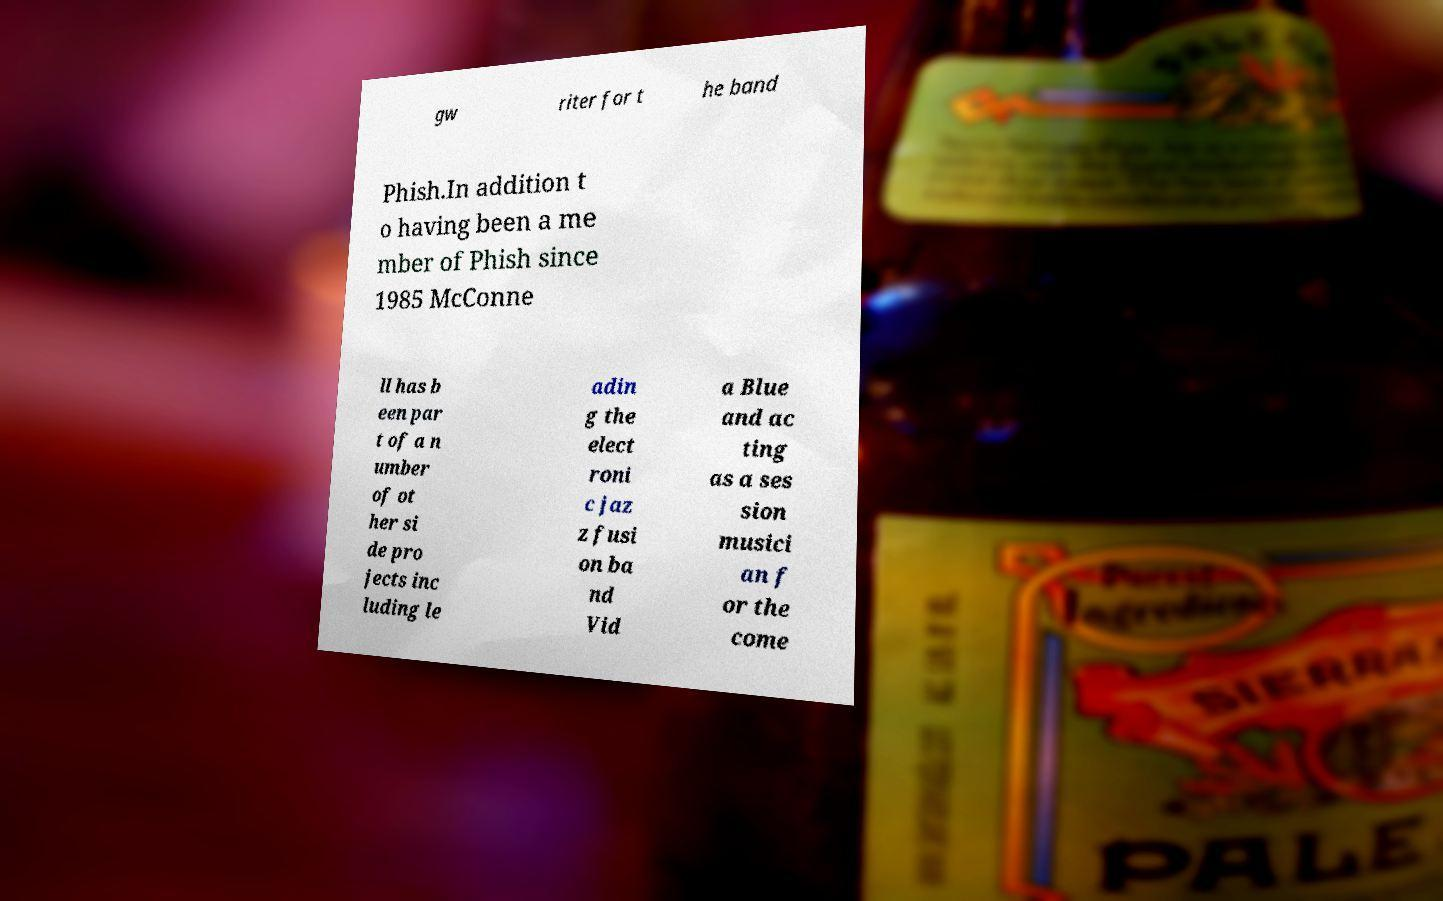Could you assist in decoding the text presented in this image and type it out clearly? gw riter for t he band Phish.In addition t o having been a me mber of Phish since 1985 McConne ll has b een par t of a n umber of ot her si de pro jects inc luding le adin g the elect roni c jaz z fusi on ba nd Vid a Blue and ac ting as a ses sion musici an f or the come 